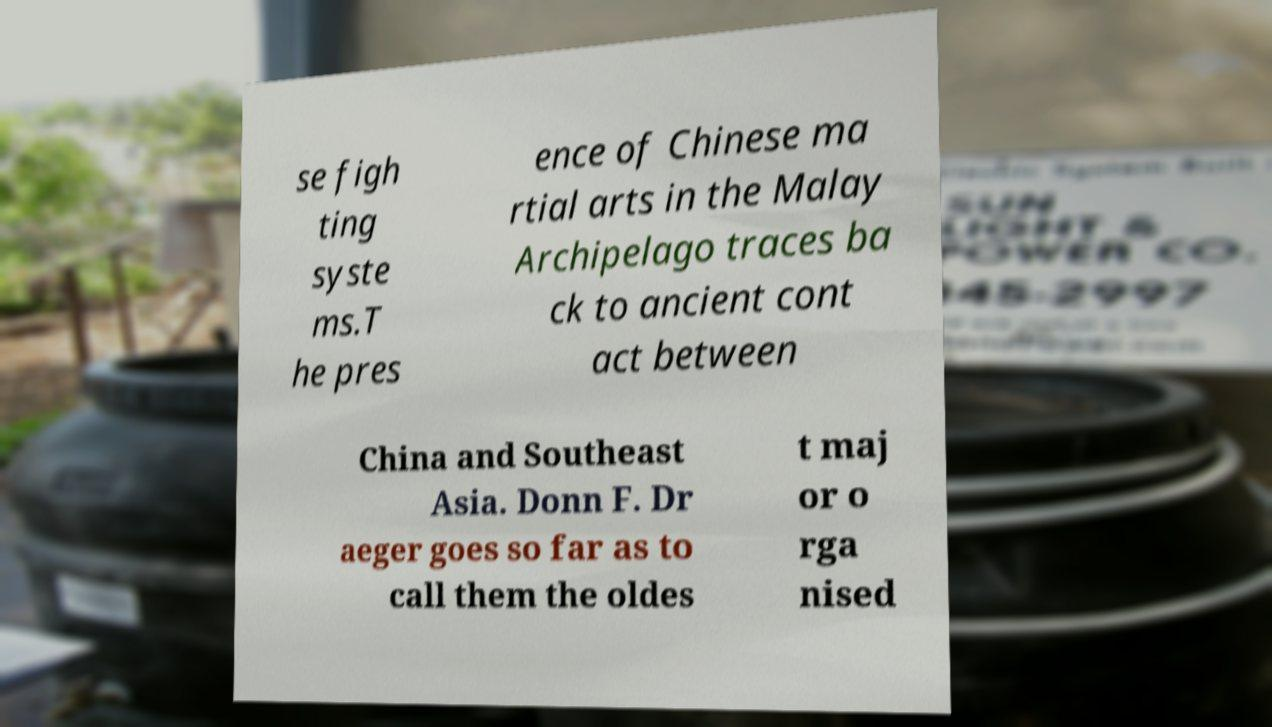Please read and relay the text visible in this image. What does it say? se figh ting syste ms.T he pres ence of Chinese ma rtial arts in the Malay Archipelago traces ba ck to ancient cont act between China and Southeast Asia. Donn F. Dr aeger goes so far as to call them the oldes t maj or o rga nised 